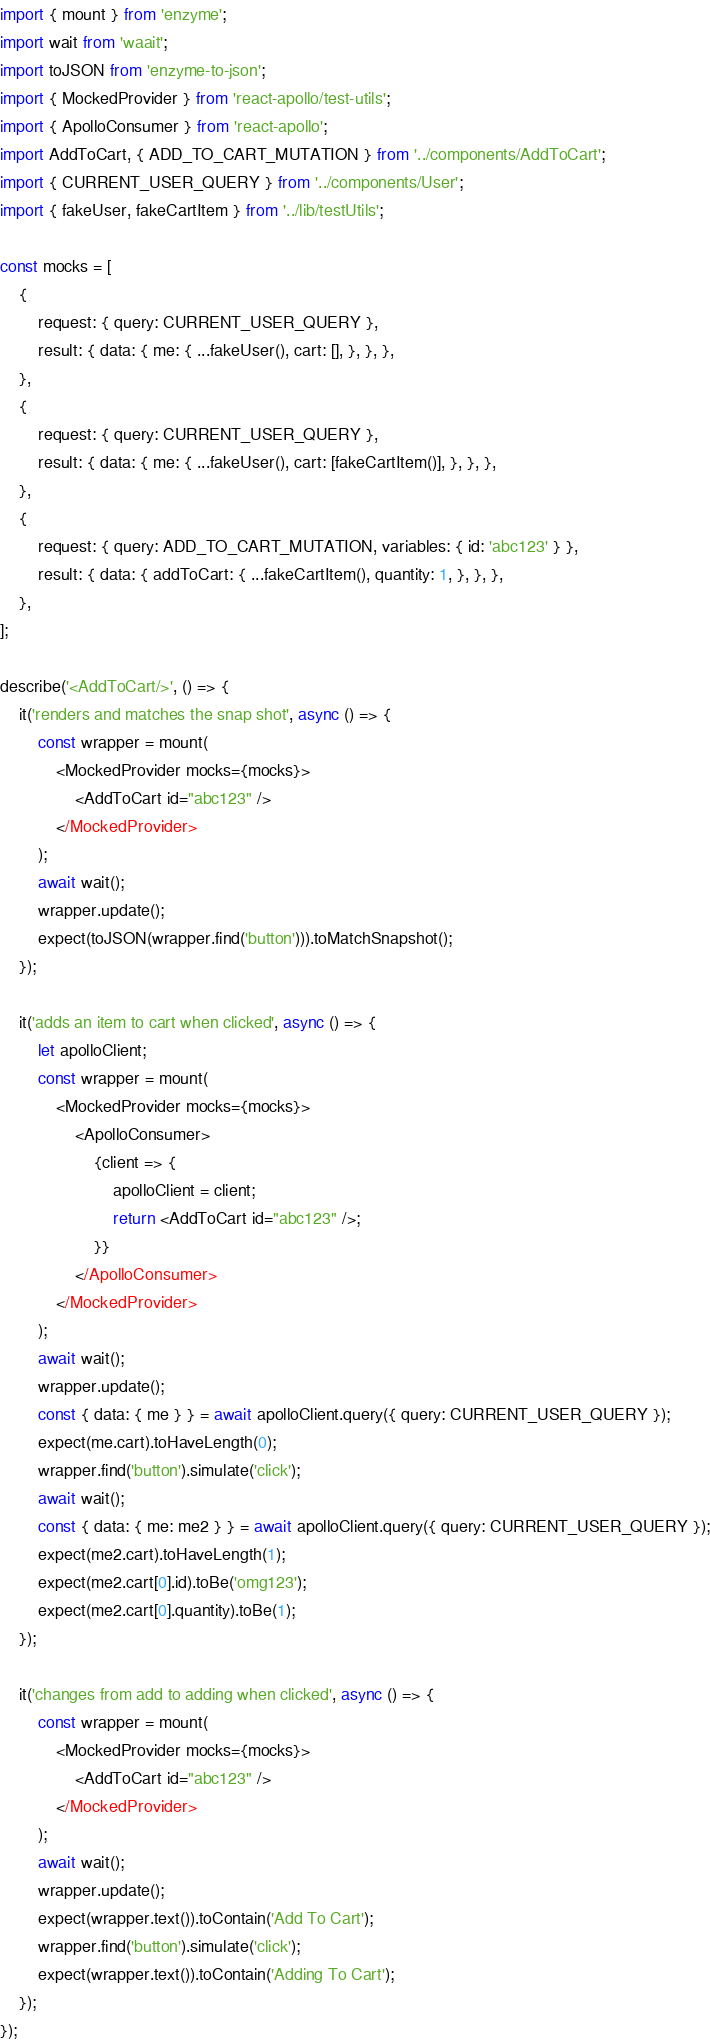Convert code to text. <code><loc_0><loc_0><loc_500><loc_500><_JavaScript_>import { mount } from 'enzyme';
import wait from 'waait';
import toJSON from 'enzyme-to-json';
import { MockedProvider } from 'react-apollo/test-utils';
import { ApolloConsumer } from 'react-apollo';
import AddToCart, { ADD_TO_CART_MUTATION } from '../components/AddToCart';
import { CURRENT_USER_QUERY } from '../components/User';
import { fakeUser, fakeCartItem } from '../lib/testUtils';

const mocks = [
    {
        request: { query: CURRENT_USER_QUERY },
        result: { data: { me: { ...fakeUser(), cart: [], }, }, },
    },
    {
        request: { query: CURRENT_USER_QUERY },
        result: { data: { me: { ...fakeUser(), cart: [fakeCartItem()], }, }, },
    },
    {
        request: { query: ADD_TO_CART_MUTATION, variables: { id: 'abc123' } },
        result: { data: { addToCart: { ...fakeCartItem(), quantity: 1, }, }, },
    },
];

describe('<AddToCart/>', () => {
    it('renders and matches the snap shot', async () => {
        const wrapper = mount(
            <MockedProvider mocks={mocks}>
                <AddToCart id="abc123" />
            </MockedProvider>
        );
        await wait();
        wrapper.update();
        expect(toJSON(wrapper.find('button'))).toMatchSnapshot();
    });

    it('adds an item to cart when clicked', async () => {
        let apolloClient;
        const wrapper = mount(
            <MockedProvider mocks={mocks}>
                <ApolloConsumer>
                    {client => {
                        apolloClient = client;
                        return <AddToCart id="abc123" />;
                    }}
                </ApolloConsumer>
            </MockedProvider>
        );
        await wait();
        wrapper.update();
        const { data: { me } } = await apolloClient.query({ query: CURRENT_USER_QUERY });
        expect(me.cart).toHaveLength(0);
        wrapper.find('button').simulate('click');
        await wait();
        const { data: { me: me2 } } = await apolloClient.query({ query: CURRENT_USER_QUERY });
        expect(me2.cart).toHaveLength(1);
        expect(me2.cart[0].id).toBe('omg123');
        expect(me2.cart[0].quantity).toBe(1);
    });

    it('changes from add to adding when clicked', async () => {
        const wrapper = mount(
            <MockedProvider mocks={mocks}>
                <AddToCart id="abc123" />
            </MockedProvider>
        );
        await wait();
        wrapper.update();
        expect(wrapper.text()).toContain('Add To Cart');
        wrapper.find('button').simulate('click');
        expect(wrapper.text()).toContain('Adding To Cart');
    });
});</code> 